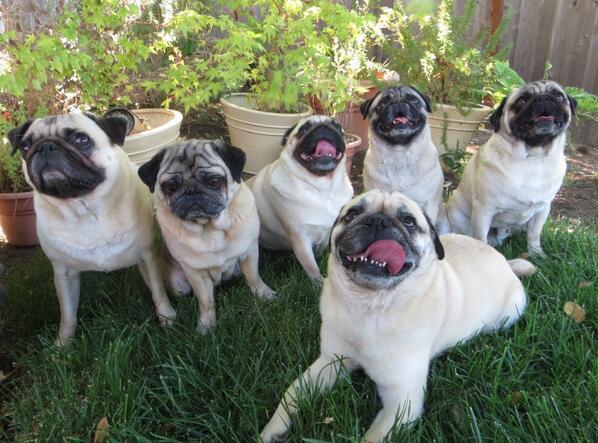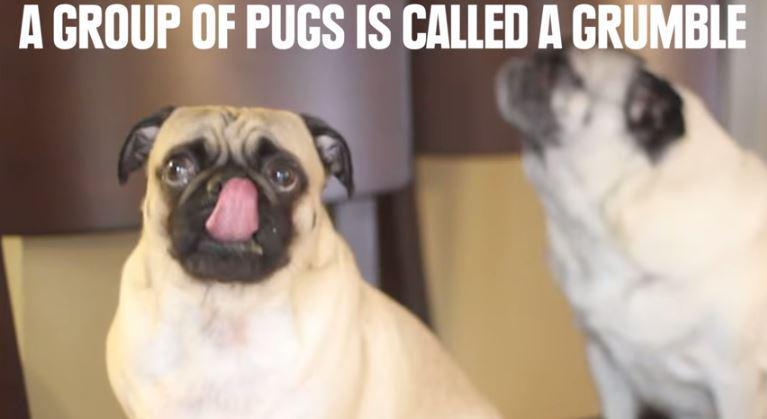The first image is the image on the left, the second image is the image on the right. Considering the images on both sides, is "there are at least five dogs in the image on the left" valid? Answer yes or no. Yes. The first image is the image on the left, the second image is the image on the right. Examine the images to the left and right. Is the description "There are more pug dogs in the left image than in the right." accurate? Answer yes or no. Yes. 